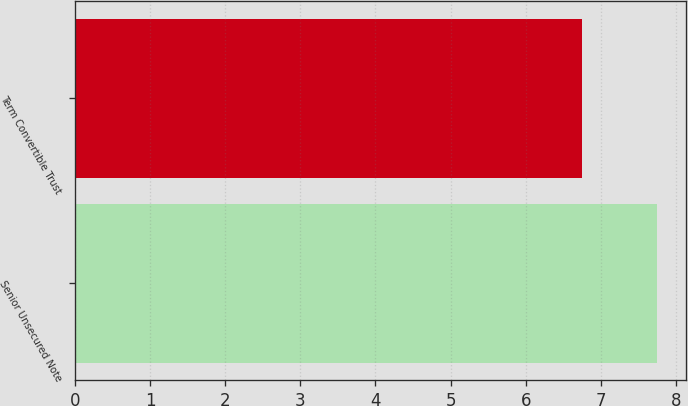<chart> <loc_0><loc_0><loc_500><loc_500><bar_chart><fcel>Senior Unsecured Note<fcel>Term Convertible Trust<nl><fcel>7.75<fcel>6.75<nl></chart> 